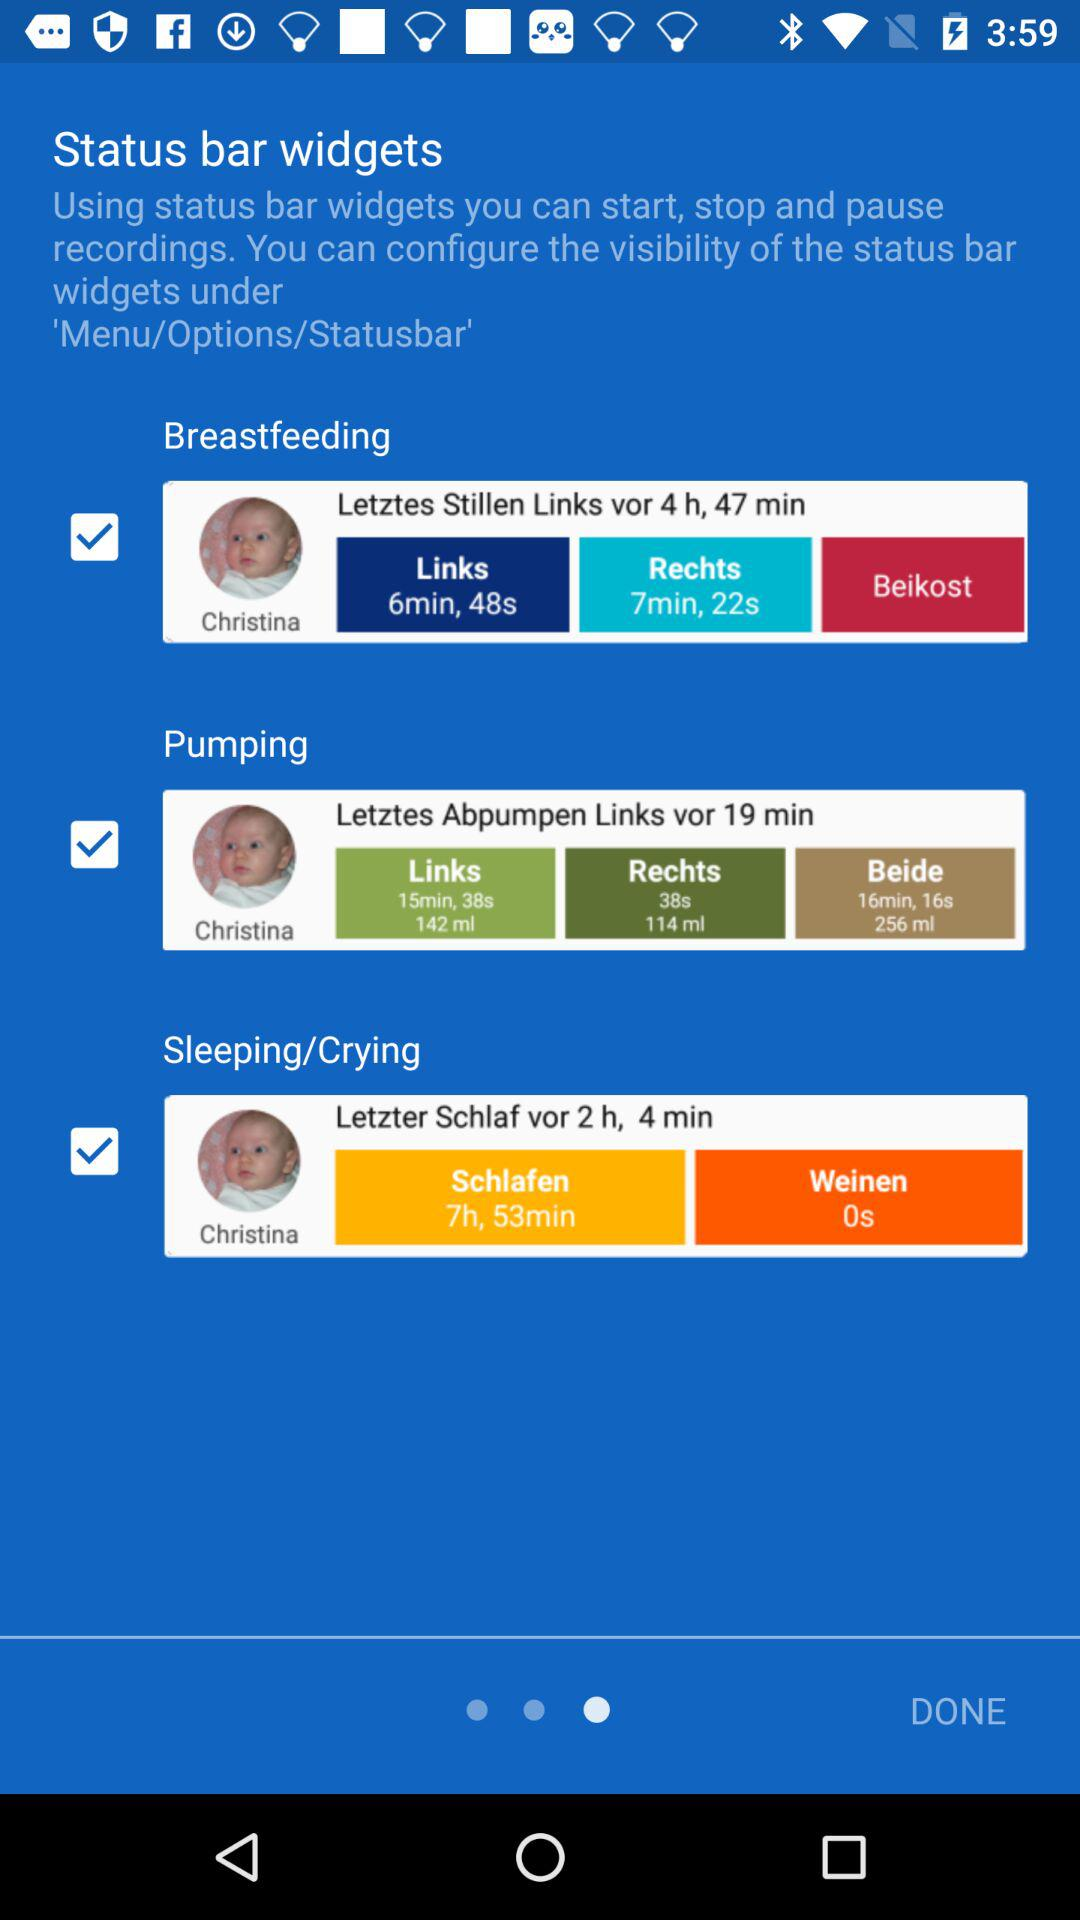How many minutes of sleep has the baby had in total?
Answer the question using a single word or phrase. 7h, 53min 